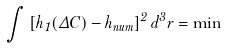Convert formula to latex. <formula><loc_0><loc_0><loc_500><loc_500>\int \left [ h _ { 1 } ( \Delta C ) - h _ { n u m } \right ] ^ { 2 } d ^ { 3 } r = \min</formula> 